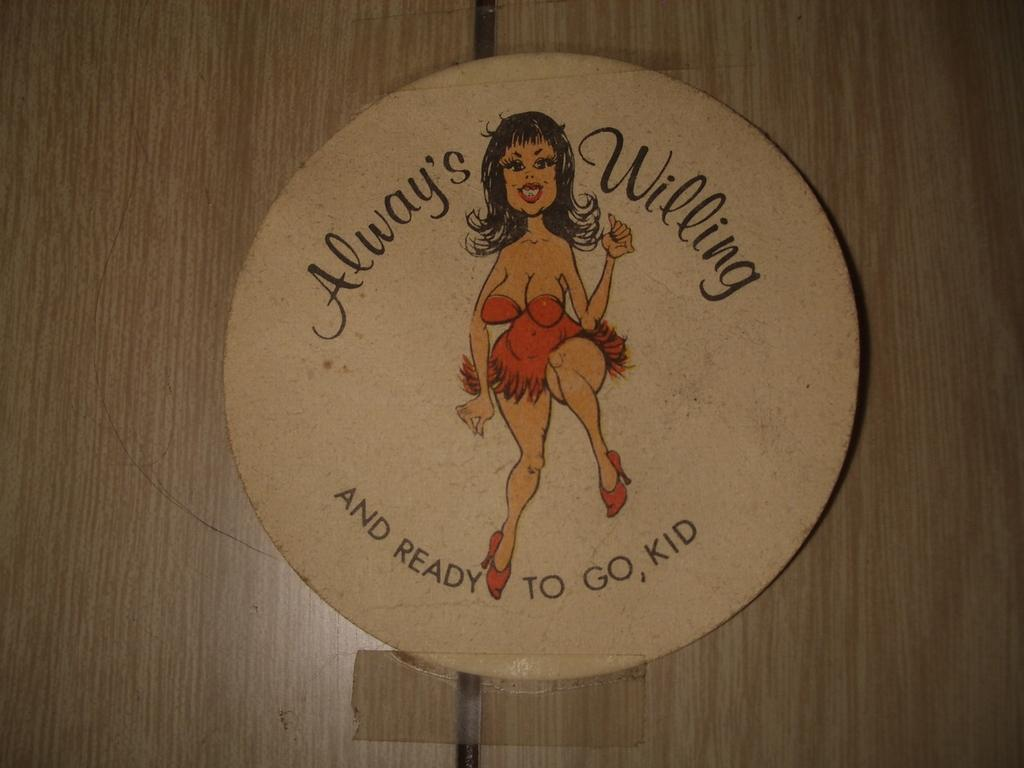What is the main object in the center of the image? There is a board in the center of the image. What can be found on the board? There is text on the board and a depiction of a woman. What type of material are the boards in the background made of? The wooden boards in the background are made of wood. How many cats are sitting on the board in the image? There are no cats present on the board or in the image. What type of laborer is depicted on the board? There is no laborer depicted on the board; it features a depiction of a woman. 